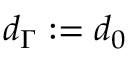<formula> <loc_0><loc_0><loc_500><loc_500>d _ { \Gamma } \colon = d _ { 0 }</formula> 